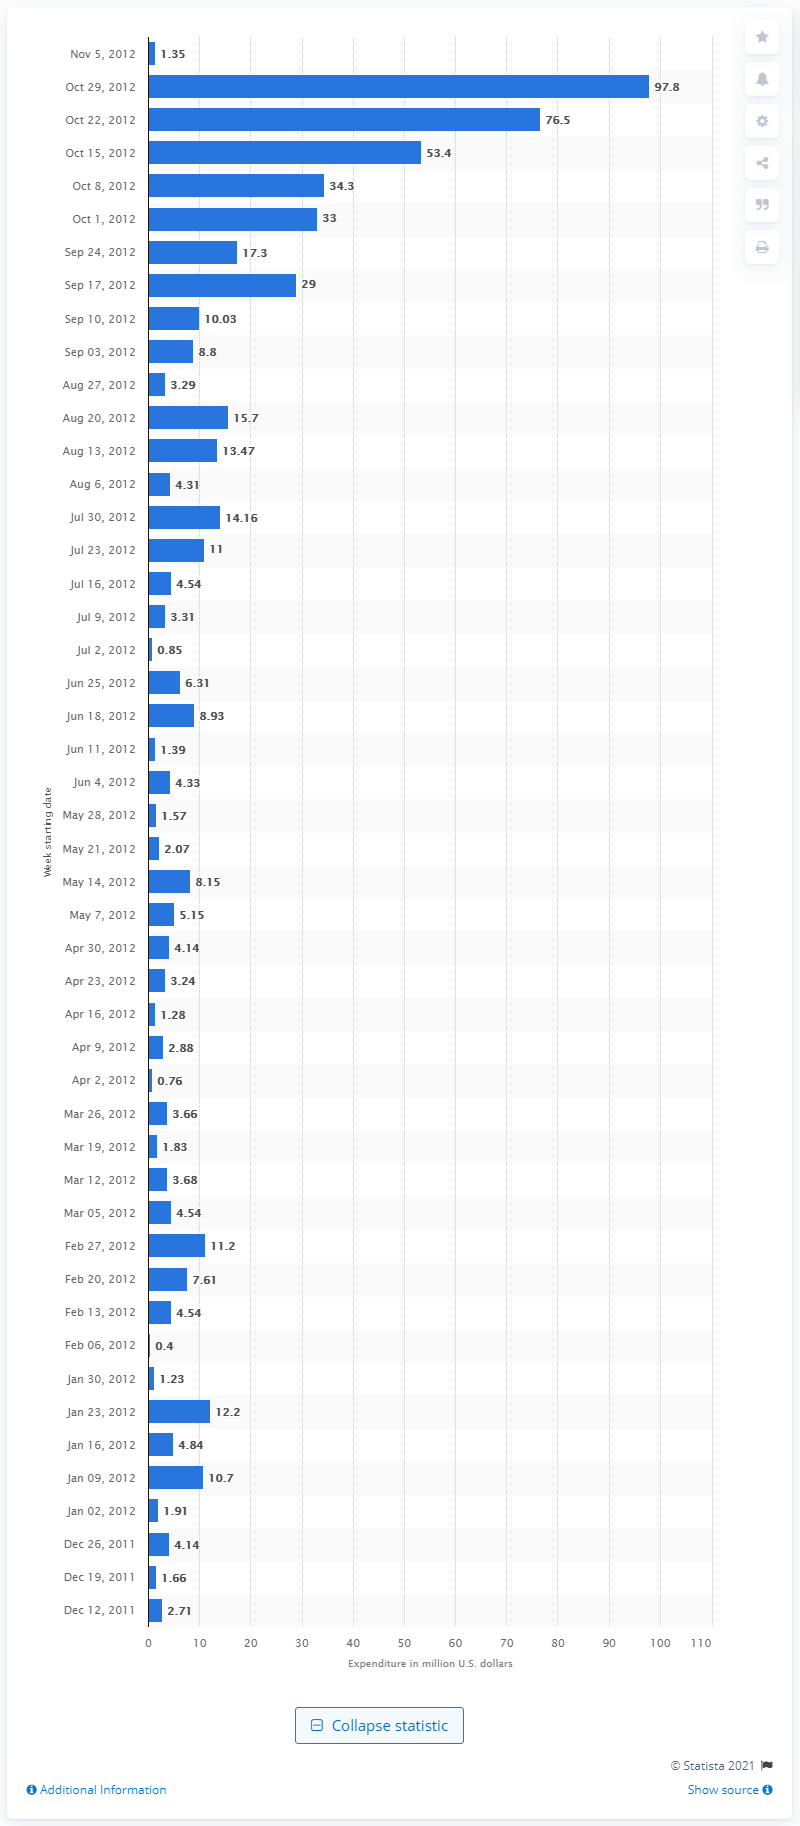Highlight a few significant elements in this photo. During the week leading up to Super Tuesday, super PACs spent a significant amount of money. 